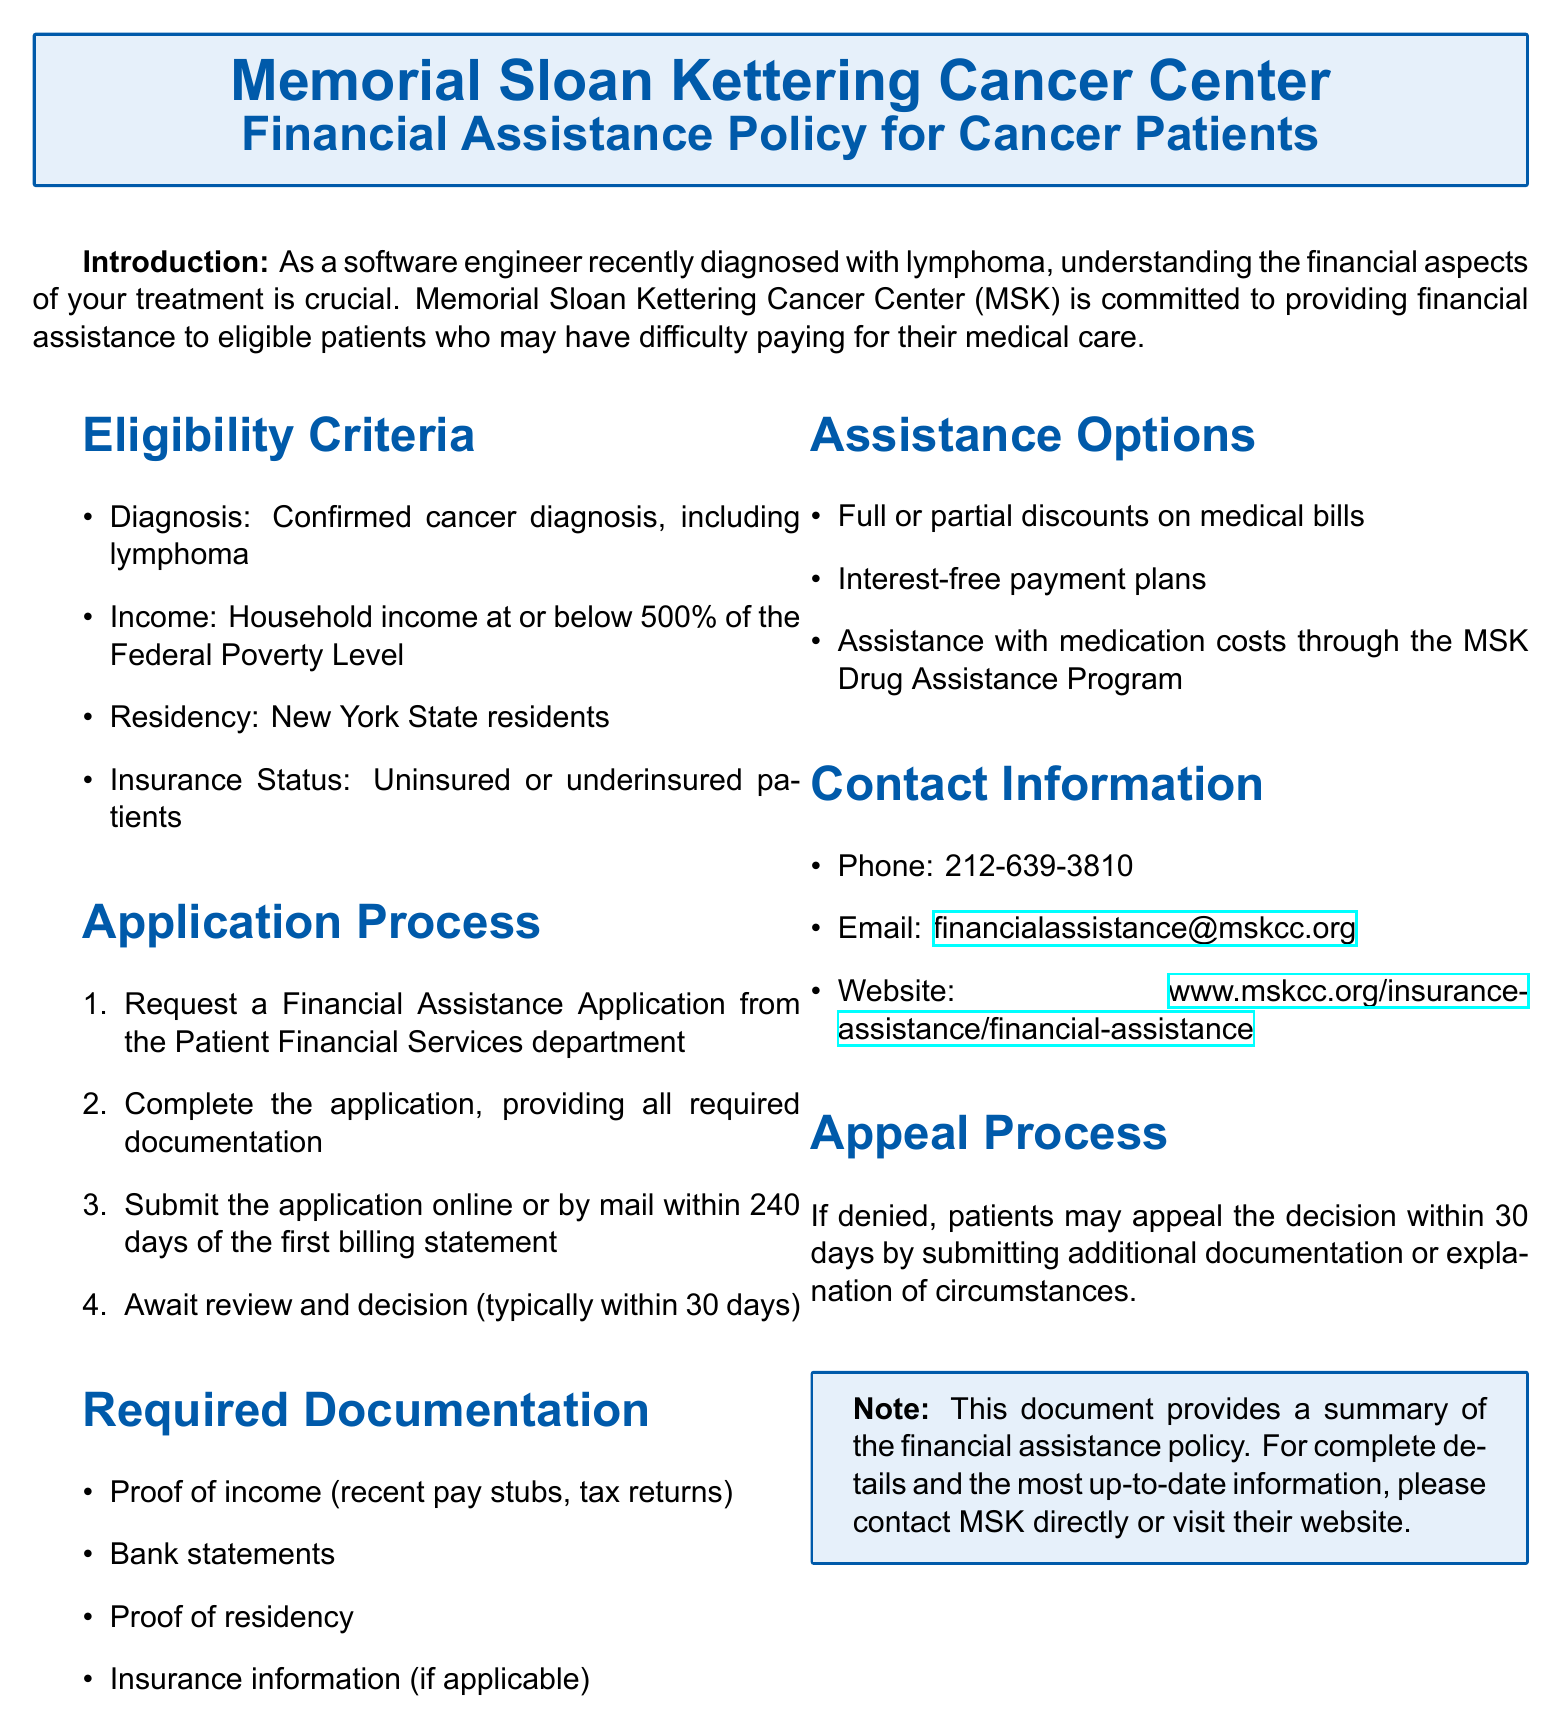What is the organization offering financial assistance? The organization providing financial assistance is mentioned in the document title.
Answer: Memorial Sloan Kettering Cancer Center What is the maximum income eligibility threshold? The document specifies the income requirement as 500% of the Federal Poverty Level.
Answer: 500% What is the residency requirement for eligibility? The document specifically states that eligible patients must be residents of New York State.
Answer: New York State How long do patients have to submit an application after the first billing statement? The application submission deadline after the first billing statement is indicated in the application process.
Answer: 240 days What type of assistance is provided under the financial assistance policy? The assistance options listed in the document highlight what kind of financial support is available.
Answer: Full or partial discounts on medical bills What is the contact phone number for financial assistance inquiries? The document includes a contact information section, which provides the phone number for inquiries.
Answer: 212-639-3810 What should patients do if their application is denied? The appeal process outlined in the document explains the steps for patients in case of denial.
Answer: Submit additional documentation or explanation of circumstances Which form of assistance helps with medication costs? The document mentions a specific program aimed at assisting with medication costs for eligible patients.
Answer: MSK Drug Assistance Program What is the typical timeframe for the application review decision? The application process describes how long patients generally wait for a decision after submitting their application.
Answer: 30 days 